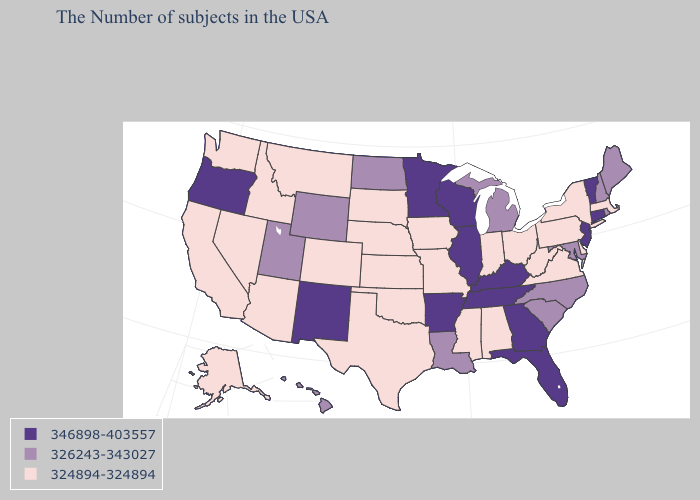Which states have the lowest value in the MidWest?
Answer briefly. Ohio, Indiana, Missouri, Iowa, Kansas, Nebraska, South Dakota. Among the states that border Wisconsin , which have the lowest value?
Write a very short answer. Iowa. What is the lowest value in the USA?
Concise answer only. 324894-324894. Which states have the lowest value in the West?
Give a very brief answer. Colorado, Montana, Arizona, Idaho, Nevada, California, Washington, Alaska. What is the value of Oklahoma?
Give a very brief answer. 324894-324894. What is the lowest value in the Northeast?
Write a very short answer. 324894-324894. What is the highest value in the West ?
Keep it brief. 346898-403557. Name the states that have a value in the range 324894-324894?
Keep it brief. Massachusetts, New York, Delaware, Pennsylvania, Virginia, West Virginia, Ohio, Indiana, Alabama, Mississippi, Missouri, Iowa, Kansas, Nebraska, Oklahoma, Texas, South Dakota, Colorado, Montana, Arizona, Idaho, Nevada, California, Washington, Alaska. What is the value of Indiana?
Be succinct. 324894-324894. Does Iowa have the highest value in the MidWest?
Write a very short answer. No. Name the states that have a value in the range 324894-324894?
Be succinct. Massachusetts, New York, Delaware, Pennsylvania, Virginia, West Virginia, Ohio, Indiana, Alabama, Mississippi, Missouri, Iowa, Kansas, Nebraska, Oklahoma, Texas, South Dakota, Colorado, Montana, Arizona, Idaho, Nevada, California, Washington, Alaska. What is the value of Maryland?
Answer briefly. 326243-343027. Which states have the lowest value in the USA?
Short answer required. Massachusetts, New York, Delaware, Pennsylvania, Virginia, West Virginia, Ohio, Indiana, Alabama, Mississippi, Missouri, Iowa, Kansas, Nebraska, Oklahoma, Texas, South Dakota, Colorado, Montana, Arizona, Idaho, Nevada, California, Washington, Alaska. Which states have the lowest value in the MidWest?
Quick response, please. Ohio, Indiana, Missouri, Iowa, Kansas, Nebraska, South Dakota. Does South Dakota have the lowest value in the USA?
Answer briefly. Yes. 